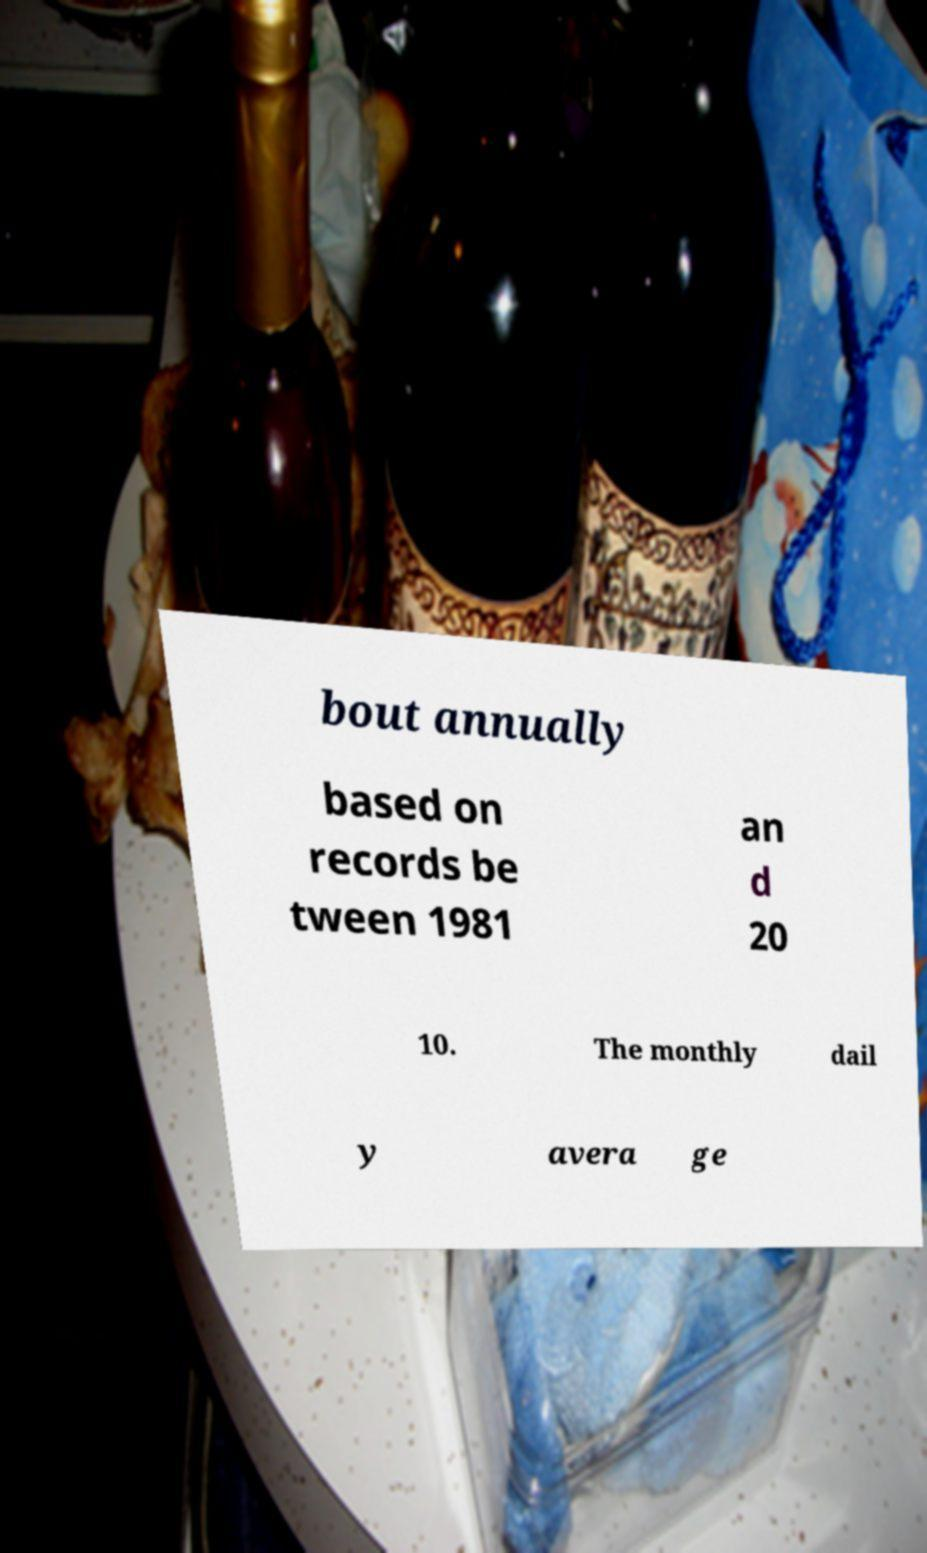Please read and relay the text visible in this image. What does it say? bout annually based on records be tween 1981 an d 20 10. The monthly dail y avera ge 